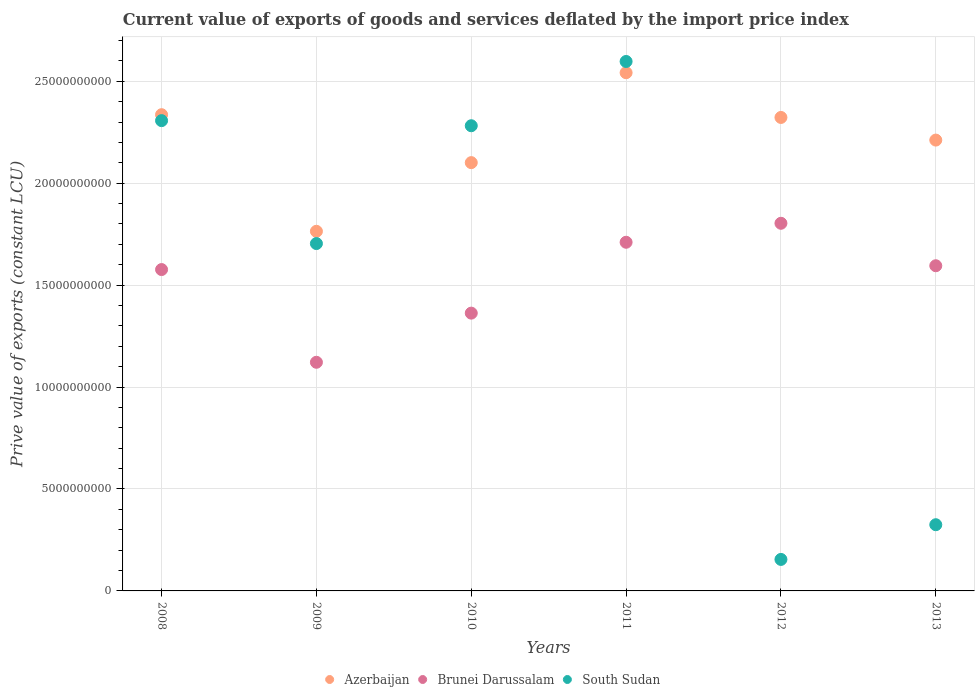What is the prive value of exports in Brunei Darussalam in 2011?
Provide a short and direct response. 1.71e+1. Across all years, what is the maximum prive value of exports in Azerbaijan?
Make the answer very short. 2.54e+1. Across all years, what is the minimum prive value of exports in South Sudan?
Your answer should be very brief. 1.55e+09. In which year was the prive value of exports in Azerbaijan maximum?
Make the answer very short. 2011. What is the total prive value of exports in South Sudan in the graph?
Provide a short and direct response. 9.37e+1. What is the difference between the prive value of exports in South Sudan in 2009 and that in 2011?
Provide a succinct answer. -8.93e+09. What is the difference between the prive value of exports in Azerbaijan in 2011 and the prive value of exports in Brunei Darussalam in 2009?
Your answer should be compact. 1.42e+1. What is the average prive value of exports in Azerbaijan per year?
Your response must be concise. 2.21e+1. In the year 2008, what is the difference between the prive value of exports in Brunei Darussalam and prive value of exports in Azerbaijan?
Offer a terse response. -7.60e+09. What is the ratio of the prive value of exports in South Sudan in 2010 to that in 2011?
Provide a succinct answer. 0.88. Is the difference between the prive value of exports in Brunei Darussalam in 2008 and 2011 greater than the difference between the prive value of exports in Azerbaijan in 2008 and 2011?
Offer a very short reply. Yes. What is the difference between the highest and the second highest prive value of exports in Brunei Darussalam?
Give a very brief answer. 9.31e+08. What is the difference between the highest and the lowest prive value of exports in Brunei Darussalam?
Provide a short and direct response. 6.82e+09. Does the prive value of exports in Brunei Darussalam monotonically increase over the years?
Your response must be concise. No. Is the prive value of exports in South Sudan strictly greater than the prive value of exports in Azerbaijan over the years?
Provide a short and direct response. No. How many dotlines are there?
Give a very brief answer. 3. How many years are there in the graph?
Provide a short and direct response. 6. Are the values on the major ticks of Y-axis written in scientific E-notation?
Give a very brief answer. No. How many legend labels are there?
Give a very brief answer. 3. What is the title of the graph?
Offer a very short reply. Current value of exports of goods and services deflated by the import price index. Does "Micronesia" appear as one of the legend labels in the graph?
Provide a short and direct response. No. What is the label or title of the X-axis?
Offer a very short reply. Years. What is the label or title of the Y-axis?
Make the answer very short. Prive value of exports (constant LCU). What is the Prive value of exports (constant LCU) of Azerbaijan in 2008?
Provide a succinct answer. 2.34e+1. What is the Prive value of exports (constant LCU) in Brunei Darussalam in 2008?
Ensure brevity in your answer.  1.58e+1. What is the Prive value of exports (constant LCU) of South Sudan in 2008?
Ensure brevity in your answer.  2.31e+1. What is the Prive value of exports (constant LCU) of Azerbaijan in 2009?
Offer a very short reply. 1.76e+1. What is the Prive value of exports (constant LCU) of Brunei Darussalam in 2009?
Provide a succinct answer. 1.12e+1. What is the Prive value of exports (constant LCU) in South Sudan in 2009?
Ensure brevity in your answer.  1.70e+1. What is the Prive value of exports (constant LCU) of Azerbaijan in 2010?
Ensure brevity in your answer.  2.10e+1. What is the Prive value of exports (constant LCU) of Brunei Darussalam in 2010?
Your answer should be compact. 1.36e+1. What is the Prive value of exports (constant LCU) in South Sudan in 2010?
Offer a very short reply. 2.28e+1. What is the Prive value of exports (constant LCU) in Azerbaijan in 2011?
Provide a succinct answer. 2.54e+1. What is the Prive value of exports (constant LCU) in Brunei Darussalam in 2011?
Your answer should be compact. 1.71e+1. What is the Prive value of exports (constant LCU) of South Sudan in 2011?
Ensure brevity in your answer.  2.60e+1. What is the Prive value of exports (constant LCU) in Azerbaijan in 2012?
Offer a very short reply. 2.32e+1. What is the Prive value of exports (constant LCU) in Brunei Darussalam in 2012?
Make the answer very short. 1.80e+1. What is the Prive value of exports (constant LCU) in South Sudan in 2012?
Your response must be concise. 1.55e+09. What is the Prive value of exports (constant LCU) of Azerbaijan in 2013?
Provide a short and direct response. 2.21e+1. What is the Prive value of exports (constant LCU) of Brunei Darussalam in 2013?
Your response must be concise. 1.60e+1. What is the Prive value of exports (constant LCU) of South Sudan in 2013?
Your answer should be very brief. 3.25e+09. Across all years, what is the maximum Prive value of exports (constant LCU) in Azerbaijan?
Offer a terse response. 2.54e+1. Across all years, what is the maximum Prive value of exports (constant LCU) in Brunei Darussalam?
Offer a terse response. 1.80e+1. Across all years, what is the maximum Prive value of exports (constant LCU) of South Sudan?
Offer a terse response. 2.60e+1. Across all years, what is the minimum Prive value of exports (constant LCU) in Azerbaijan?
Your answer should be compact. 1.76e+1. Across all years, what is the minimum Prive value of exports (constant LCU) of Brunei Darussalam?
Give a very brief answer. 1.12e+1. Across all years, what is the minimum Prive value of exports (constant LCU) in South Sudan?
Make the answer very short. 1.55e+09. What is the total Prive value of exports (constant LCU) in Azerbaijan in the graph?
Provide a short and direct response. 1.33e+11. What is the total Prive value of exports (constant LCU) of Brunei Darussalam in the graph?
Your answer should be very brief. 9.17e+1. What is the total Prive value of exports (constant LCU) of South Sudan in the graph?
Make the answer very short. 9.37e+1. What is the difference between the Prive value of exports (constant LCU) of Azerbaijan in 2008 and that in 2009?
Provide a succinct answer. 5.72e+09. What is the difference between the Prive value of exports (constant LCU) in Brunei Darussalam in 2008 and that in 2009?
Ensure brevity in your answer.  4.55e+09. What is the difference between the Prive value of exports (constant LCU) in South Sudan in 2008 and that in 2009?
Offer a very short reply. 6.03e+09. What is the difference between the Prive value of exports (constant LCU) of Azerbaijan in 2008 and that in 2010?
Offer a very short reply. 2.35e+09. What is the difference between the Prive value of exports (constant LCU) of Brunei Darussalam in 2008 and that in 2010?
Your response must be concise. 2.14e+09. What is the difference between the Prive value of exports (constant LCU) in South Sudan in 2008 and that in 2010?
Your response must be concise. 2.50e+08. What is the difference between the Prive value of exports (constant LCU) in Azerbaijan in 2008 and that in 2011?
Keep it short and to the point. -2.06e+09. What is the difference between the Prive value of exports (constant LCU) in Brunei Darussalam in 2008 and that in 2011?
Offer a terse response. -1.34e+09. What is the difference between the Prive value of exports (constant LCU) in South Sudan in 2008 and that in 2011?
Provide a short and direct response. -2.90e+09. What is the difference between the Prive value of exports (constant LCU) of Azerbaijan in 2008 and that in 2012?
Make the answer very short. 1.35e+08. What is the difference between the Prive value of exports (constant LCU) of Brunei Darussalam in 2008 and that in 2012?
Your response must be concise. -2.27e+09. What is the difference between the Prive value of exports (constant LCU) of South Sudan in 2008 and that in 2012?
Ensure brevity in your answer.  2.15e+1. What is the difference between the Prive value of exports (constant LCU) of Azerbaijan in 2008 and that in 2013?
Your response must be concise. 1.25e+09. What is the difference between the Prive value of exports (constant LCU) of Brunei Darussalam in 2008 and that in 2013?
Make the answer very short. -1.87e+08. What is the difference between the Prive value of exports (constant LCU) in South Sudan in 2008 and that in 2013?
Make the answer very short. 1.98e+1. What is the difference between the Prive value of exports (constant LCU) of Azerbaijan in 2009 and that in 2010?
Ensure brevity in your answer.  -3.37e+09. What is the difference between the Prive value of exports (constant LCU) of Brunei Darussalam in 2009 and that in 2010?
Make the answer very short. -2.41e+09. What is the difference between the Prive value of exports (constant LCU) of South Sudan in 2009 and that in 2010?
Make the answer very short. -5.78e+09. What is the difference between the Prive value of exports (constant LCU) in Azerbaijan in 2009 and that in 2011?
Offer a very short reply. -7.78e+09. What is the difference between the Prive value of exports (constant LCU) in Brunei Darussalam in 2009 and that in 2011?
Your answer should be very brief. -5.89e+09. What is the difference between the Prive value of exports (constant LCU) in South Sudan in 2009 and that in 2011?
Keep it short and to the point. -8.93e+09. What is the difference between the Prive value of exports (constant LCU) of Azerbaijan in 2009 and that in 2012?
Your answer should be compact. -5.58e+09. What is the difference between the Prive value of exports (constant LCU) of Brunei Darussalam in 2009 and that in 2012?
Offer a terse response. -6.82e+09. What is the difference between the Prive value of exports (constant LCU) in South Sudan in 2009 and that in 2012?
Make the answer very short. 1.55e+1. What is the difference between the Prive value of exports (constant LCU) of Azerbaijan in 2009 and that in 2013?
Provide a short and direct response. -4.47e+09. What is the difference between the Prive value of exports (constant LCU) in Brunei Darussalam in 2009 and that in 2013?
Offer a very short reply. -4.74e+09. What is the difference between the Prive value of exports (constant LCU) of South Sudan in 2009 and that in 2013?
Keep it short and to the point. 1.38e+1. What is the difference between the Prive value of exports (constant LCU) of Azerbaijan in 2010 and that in 2011?
Your answer should be very brief. -4.41e+09. What is the difference between the Prive value of exports (constant LCU) in Brunei Darussalam in 2010 and that in 2011?
Ensure brevity in your answer.  -3.48e+09. What is the difference between the Prive value of exports (constant LCU) in South Sudan in 2010 and that in 2011?
Give a very brief answer. -3.15e+09. What is the difference between the Prive value of exports (constant LCU) of Azerbaijan in 2010 and that in 2012?
Offer a terse response. -2.22e+09. What is the difference between the Prive value of exports (constant LCU) in Brunei Darussalam in 2010 and that in 2012?
Your answer should be very brief. -4.41e+09. What is the difference between the Prive value of exports (constant LCU) of South Sudan in 2010 and that in 2012?
Provide a short and direct response. 2.13e+1. What is the difference between the Prive value of exports (constant LCU) in Azerbaijan in 2010 and that in 2013?
Provide a short and direct response. -1.11e+09. What is the difference between the Prive value of exports (constant LCU) of Brunei Darussalam in 2010 and that in 2013?
Offer a very short reply. -2.33e+09. What is the difference between the Prive value of exports (constant LCU) in South Sudan in 2010 and that in 2013?
Your answer should be very brief. 1.96e+1. What is the difference between the Prive value of exports (constant LCU) of Azerbaijan in 2011 and that in 2012?
Provide a succinct answer. 2.19e+09. What is the difference between the Prive value of exports (constant LCU) in Brunei Darussalam in 2011 and that in 2012?
Offer a terse response. -9.31e+08. What is the difference between the Prive value of exports (constant LCU) of South Sudan in 2011 and that in 2012?
Provide a succinct answer. 2.44e+1. What is the difference between the Prive value of exports (constant LCU) of Azerbaijan in 2011 and that in 2013?
Your answer should be compact. 3.31e+09. What is the difference between the Prive value of exports (constant LCU) of Brunei Darussalam in 2011 and that in 2013?
Keep it short and to the point. 1.15e+09. What is the difference between the Prive value of exports (constant LCU) in South Sudan in 2011 and that in 2013?
Your answer should be very brief. 2.27e+1. What is the difference between the Prive value of exports (constant LCU) of Azerbaijan in 2012 and that in 2013?
Offer a terse response. 1.11e+09. What is the difference between the Prive value of exports (constant LCU) of Brunei Darussalam in 2012 and that in 2013?
Keep it short and to the point. 2.08e+09. What is the difference between the Prive value of exports (constant LCU) in South Sudan in 2012 and that in 2013?
Make the answer very short. -1.70e+09. What is the difference between the Prive value of exports (constant LCU) in Azerbaijan in 2008 and the Prive value of exports (constant LCU) in Brunei Darussalam in 2009?
Offer a very short reply. 1.21e+1. What is the difference between the Prive value of exports (constant LCU) in Azerbaijan in 2008 and the Prive value of exports (constant LCU) in South Sudan in 2009?
Ensure brevity in your answer.  6.32e+09. What is the difference between the Prive value of exports (constant LCU) in Brunei Darussalam in 2008 and the Prive value of exports (constant LCU) in South Sudan in 2009?
Your answer should be compact. -1.28e+09. What is the difference between the Prive value of exports (constant LCU) of Azerbaijan in 2008 and the Prive value of exports (constant LCU) of Brunei Darussalam in 2010?
Provide a short and direct response. 9.73e+09. What is the difference between the Prive value of exports (constant LCU) in Azerbaijan in 2008 and the Prive value of exports (constant LCU) in South Sudan in 2010?
Your answer should be very brief. 5.42e+08. What is the difference between the Prive value of exports (constant LCU) of Brunei Darussalam in 2008 and the Prive value of exports (constant LCU) of South Sudan in 2010?
Your answer should be very brief. -7.06e+09. What is the difference between the Prive value of exports (constant LCU) in Azerbaijan in 2008 and the Prive value of exports (constant LCU) in Brunei Darussalam in 2011?
Your answer should be compact. 6.26e+09. What is the difference between the Prive value of exports (constant LCU) of Azerbaijan in 2008 and the Prive value of exports (constant LCU) of South Sudan in 2011?
Provide a succinct answer. -2.61e+09. What is the difference between the Prive value of exports (constant LCU) in Brunei Darussalam in 2008 and the Prive value of exports (constant LCU) in South Sudan in 2011?
Make the answer very short. -1.02e+1. What is the difference between the Prive value of exports (constant LCU) in Azerbaijan in 2008 and the Prive value of exports (constant LCU) in Brunei Darussalam in 2012?
Offer a terse response. 5.33e+09. What is the difference between the Prive value of exports (constant LCU) in Azerbaijan in 2008 and the Prive value of exports (constant LCU) in South Sudan in 2012?
Your answer should be very brief. 2.18e+1. What is the difference between the Prive value of exports (constant LCU) in Brunei Darussalam in 2008 and the Prive value of exports (constant LCU) in South Sudan in 2012?
Provide a short and direct response. 1.42e+1. What is the difference between the Prive value of exports (constant LCU) in Azerbaijan in 2008 and the Prive value of exports (constant LCU) in Brunei Darussalam in 2013?
Provide a short and direct response. 7.41e+09. What is the difference between the Prive value of exports (constant LCU) of Azerbaijan in 2008 and the Prive value of exports (constant LCU) of South Sudan in 2013?
Offer a very short reply. 2.01e+1. What is the difference between the Prive value of exports (constant LCU) in Brunei Darussalam in 2008 and the Prive value of exports (constant LCU) in South Sudan in 2013?
Your response must be concise. 1.25e+1. What is the difference between the Prive value of exports (constant LCU) in Azerbaijan in 2009 and the Prive value of exports (constant LCU) in Brunei Darussalam in 2010?
Make the answer very short. 4.01e+09. What is the difference between the Prive value of exports (constant LCU) of Azerbaijan in 2009 and the Prive value of exports (constant LCU) of South Sudan in 2010?
Keep it short and to the point. -5.18e+09. What is the difference between the Prive value of exports (constant LCU) of Brunei Darussalam in 2009 and the Prive value of exports (constant LCU) of South Sudan in 2010?
Give a very brief answer. -1.16e+1. What is the difference between the Prive value of exports (constant LCU) of Azerbaijan in 2009 and the Prive value of exports (constant LCU) of Brunei Darussalam in 2011?
Give a very brief answer. 5.38e+08. What is the difference between the Prive value of exports (constant LCU) in Azerbaijan in 2009 and the Prive value of exports (constant LCU) in South Sudan in 2011?
Give a very brief answer. -8.33e+09. What is the difference between the Prive value of exports (constant LCU) of Brunei Darussalam in 2009 and the Prive value of exports (constant LCU) of South Sudan in 2011?
Keep it short and to the point. -1.48e+1. What is the difference between the Prive value of exports (constant LCU) of Azerbaijan in 2009 and the Prive value of exports (constant LCU) of Brunei Darussalam in 2012?
Ensure brevity in your answer.  -3.93e+08. What is the difference between the Prive value of exports (constant LCU) in Azerbaijan in 2009 and the Prive value of exports (constant LCU) in South Sudan in 2012?
Give a very brief answer. 1.61e+1. What is the difference between the Prive value of exports (constant LCU) of Brunei Darussalam in 2009 and the Prive value of exports (constant LCU) of South Sudan in 2012?
Provide a succinct answer. 9.67e+09. What is the difference between the Prive value of exports (constant LCU) of Azerbaijan in 2009 and the Prive value of exports (constant LCU) of Brunei Darussalam in 2013?
Your answer should be compact. 1.69e+09. What is the difference between the Prive value of exports (constant LCU) in Azerbaijan in 2009 and the Prive value of exports (constant LCU) in South Sudan in 2013?
Keep it short and to the point. 1.44e+1. What is the difference between the Prive value of exports (constant LCU) of Brunei Darussalam in 2009 and the Prive value of exports (constant LCU) of South Sudan in 2013?
Offer a terse response. 7.97e+09. What is the difference between the Prive value of exports (constant LCU) in Azerbaijan in 2010 and the Prive value of exports (constant LCU) in Brunei Darussalam in 2011?
Make the answer very short. 3.91e+09. What is the difference between the Prive value of exports (constant LCU) of Azerbaijan in 2010 and the Prive value of exports (constant LCU) of South Sudan in 2011?
Ensure brevity in your answer.  -4.96e+09. What is the difference between the Prive value of exports (constant LCU) in Brunei Darussalam in 2010 and the Prive value of exports (constant LCU) in South Sudan in 2011?
Keep it short and to the point. -1.23e+1. What is the difference between the Prive value of exports (constant LCU) in Azerbaijan in 2010 and the Prive value of exports (constant LCU) in Brunei Darussalam in 2012?
Provide a short and direct response. 2.98e+09. What is the difference between the Prive value of exports (constant LCU) in Azerbaijan in 2010 and the Prive value of exports (constant LCU) in South Sudan in 2012?
Ensure brevity in your answer.  1.95e+1. What is the difference between the Prive value of exports (constant LCU) in Brunei Darussalam in 2010 and the Prive value of exports (constant LCU) in South Sudan in 2012?
Your response must be concise. 1.21e+1. What is the difference between the Prive value of exports (constant LCU) of Azerbaijan in 2010 and the Prive value of exports (constant LCU) of Brunei Darussalam in 2013?
Give a very brief answer. 5.06e+09. What is the difference between the Prive value of exports (constant LCU) of Azerbaijan in 2010 and the Prive value of exports (constant LCU) of South Sudan in 2013?
Your answer should be compact. 1.78e+1. What is the difference between the Prive value of exports (constant LCU) of Brunei Darussalam in 2010 and the Prive value of exports (constant LCU) of South Sudan in 2013?
Your answer should be compact. 1.04e+1. What is the difference between the Prive value of exports (constant LCU) in Azerbaijan in 2011 and the Prive value of exports (constant LCU) in Brunei Darussalam in 2012?
Provide a short and direct response. 7.39e+09. What is the difference between the Prive value of exports (constant LCU) in Azerbaijan in 2011 and the Prive value of exports (constant LCU) in South Sudan in 2012?
Ensure brevity in your answer.  2.39e+1. What is the difference between the Prive value of exports (constant LCU) of Brunei Darussalam in 2011 and the Prive value of exports (constant LCU) of South Sudan in 2012?
Provide a succinct answer. 1.56e+1. What is the difference between the Prive value of exports (constant LCU) of Azerbaijan in 2011 and the Prive value of exports (constant LCU) of Brunei Darussalam in 2013?
Give a very brief answer. 9.47e+09. What is the difference between the Prive value of exports (constant LCU) in Azerbaijan in 2011 and the Prive value of exports (constant LCU) in South Sudan in 2013?
Give a very brief answer. 2.22e+1. What is the difference between the Prive value of exports (constant LCU) in Brunei Darussalam in 2011 and the Prive value of exports (constant LCU) in South Sudan in 2013?
Your response must be concise. 1.39e+1. What is the difference between the Prive value of exports (constant LCU) in Azerbaijan in 2012 and the Prive value of exports (constant LCU) in Brunei Darussalam in 2013?
Make the answer very short. 7.27e+09. What is the difference between the Prive value of exports (constant LCU) in Azerbaijan in 2012 and the Prive value of exports (constant LCU) in South Sudan in 2013?
Give a very brief answer. 2.00e+1. What is the difference between the Prive value of exports (constant LCU) in Brunei Darussalam in 2012 and the Prive value of exports (constant LCU) in South Sudan in 2013?
Keep it short and to the point. 1.48e+1. What is the average Prive value of exports (constant LCU) in Azerbaijan per year?
Provide a short and direct response. 2.21e+1. What is the average Prive value of exports (constant LCU) of Brunei Darussalam per year?
Your response must be concise. 1.53e+1. What is the average Prive value of exports (constant LCU) of South Sudan per year?
Offer a terse response. 1.56e+1. In the year 2008, what is the difference between the Prive value of exports (constant LCU) of Azerbaijan and Prive value of exports (constant LCU) of Brunei Darussalam?
Your answer should be compact. 7.60e+09. In the year 2008, what is the difference between the Prive value of exports (constant LCU) in Azerbaijan and Prive value of exports (constant LCU) in South Sudan?
Make the answer very short. 2.92e+08. In the year 2008, what is the difference between the Prive value of exports (constant LCU) in Brunei Darussalam and Prive value of exports (constant LCU) in South Sudan?
Keep it short and to the point. -7.31e+09. In the year 2009, what is the difference between the Prive value of exports (constant LCU) in Azerbaijan and Prive value of exports (constant LCU) in Brunei Darussalam?
Your response must be concise. 6.43e+09. In the year 2009, what is the difference between the Prive value of exports (constant LCU) in Azerbaijan and Prive value of exports (constant LCU) in South Sudan?
Ensure brevity in your answer.  6.01e+08. In the year 2009, what is the difference between the Prive value of exports (constant LCU) in Brunei Darussalam and Prive value of exports (constant LCU) in South Sudan?
Make the answer very short. -5.82e+09. In the year 2010, what is the difference between the Prive value of exports (constant LCU) of Azerbaijan and Prive value of exports (constant LCU) of Brunei Darussalam?
Provide a succinct answer. 7.38e+09. In the year 2010, what is the difference between the Prive value of exports (constant LCU) in Azerbaijan and Prive value of exports (constant LCU) in South Sudan?
Offer a terse response. -1.81e+09. In the year 2010, what is the difference between the Prive value of exports (constant LCU) of Brunei Darussalam and Prive value of exports (constant LCU) of South Sudan?
Your answer should be very brief. -9.19e+09. In the year 2011, what is the difference between the Prive value of exports (constant LCU) in Azerbaijan and Prive value of exports (constant LCU) in Brunei Darussalam?
Your answer should be compact. 8.32e+09. In the year 2011, what is the difference between the Prive value of exports (constant LCU) of Azerbaijan and Prive value of exports (constant LCU) of South Sudan?
Your response must be concise. -5.51e+08. In the year 2011, what is the difference between the Prive value of exports (constant LCU) in Brunei Darussalam and Prive value of exports (constant LCU) in South Sudan?
Offer a very short reply. -8.87e+09. In the year 2012, what is the difference between the Prive value of exports (constant LCU) of Azerbaijan and Prive value of exports (constant LCU) of Brunei Darussalam?
Ensure brevity in your answer.  5.19e+09. In the year 2012, what is the difference between the Prive value of exports (constant LCU) in Azerbaijan and Prive value of exports (constant LCU) in South Sudan?
Make the answer very short. 2.17e+1. In the year 2012, what is the difference between the Prive value of exports (constant LCU) in Brunei Darussalam and Prive value of exports (constant LCU) in South Sudan?
Ensure brevity in your answer.  1.65e+1. In the year 2013, what is the difference between the Prive value of exports (constant LCU) of Azerbaijan and Prive value of exports (constant LCU) of Brunei Darussalam?
Your response must be concise. 6.16e+09. In the year 2013, what is the difference between the Prive value of exports (constant LCU) of Azerbaijan and Prive value of exports (constant LCU) of South Sudan?
Give a very brief answer. 1.89e+1. In the year 2013, what is the difference between the Prive value of exports (constant LCU) in Brunei Darussalam and Prive value of exports (constant LCU) in South Sudan?
Give a very brief answer. 1.27e+1. What is the ratio of the Prive value of exports (constant LCU) in Azerbaijan in 2008 to that in 2009?
Your answer should be compact. 1.32. What is the ratio of the Prive value of exports (constant LCU) in Brunei Darussalam in 2008 to that in 2009?
Give a very brief answer. 1.41. What is the ratio of the Prive value of exports (constant LCU) of South Sudan in 2008 to that in 2009?
Offer a terse response. 1.35. What is the ratio of the Prive value of exports (constant LCU) in Azerbaijan in 2008 to that in 2010?
Offer a terse response. 1.11. What is the ratio of the Prive value of exports (constant LCU) of Brunei Darussalam in 2008 to that in 2010?
Ensure brevity in your answer.  1.16. What is the ratio of the Prive value of exports (constant LCU) in South Sudan in 2008 to that in 2010?
Give a very brief answer. 1.01. What is the ratio of the Prive value of exports (constant LCU) in Azerbaijan in 2008 to that in 2011?
Provide a short and direct response. 0.92. What is the ratio of the Prive value of exports (constant LCU) in Brunei Darussalam in 2008 to that in 2011?
Give a very brief answer. 0.92. What is the ratio of the Prive value of exports (constant LCU) of South Sudan in 2008 to that in 2011?
Provide a succinct answer. 0.89. What is the ratio of the Prive value of exports (constant LCU) of Brunei Darussalam in 2008 to that in 2012?
Your answer should be compact. 0.87. What is the ratio of the Prive value of exports (constant LCU) in South Sudan in 2008 to that in 2012?
Offer a terse response. 14.93. What is the ratio of the Prive value of exports (constant LCU) in Azerbaijan in 2008 to that in 2013?
Your answer should be very brief. 1.06. What is the ratio of the Prive value of exports (constant LCU) of Brunei Darussalam in 2008 to that in 2013?
Provide a succinct answer. 0.99. What is the ratio of the Prive value of exports (constant LCU) of South Sudan in 2008 to that in 2013?
Your answer should be compact. 7.1. What is the ratio of the Prive value of exports (constant LCU) of Azerbaijan in 2009 to that in 2010?
Keep it short and to the point. 0.84. What is the ratio of the Prive value of exports (constant LCU) of Brunei Darussalam in 2009 to that in 2010?
Make the answer very short. 0.82. What is the ratio of the Prive value of exports (constant LCU) of South Sudan in 2009 to that in 2010?
Give a very brief answer. 0.75. What is the ratio of the Prive value of exports (constant LCU) of Azerbaijan in 2009 to that in 2011?
Give a very brief answer. 0.69. What is the ratio of the Prive value of exports (constant LCU) of Brunei Darussalam in 2009 to that in 2011?
Provide a short and direct response. 0.66. What is the ratio of the Prive value of exports (constant LCU) in South Sudan in 2009 to that in 2011?
Offer a terse response. 0.66. What is the ratio of the Prive value of exports (constant LCU) of Azerbaijan in 2009 to that in 2012?
Provide a short and direct response. 0.76. What is the ratio of the Prive value of exports (constant LCU) in Brunei Darussalam in 2009 to that in 2012?
Your response must be concise. 0.62. What is the ratio of the Prive value of exports (constant LCU) of South Sudan in 2009 to that in 2012?
Give a very brief answer. 11.03. What is the ratio of the Prive value of exports (constant LCU) of Azerbaijan in 2009 to that in 2013?
Your answer should be compact. 0.8. What is the ratio of the Prive value of exports (constant LCU) of Brunei Darussalam in 2009 to that in 2013?
Offer a terse response. 0.7. What is the ratio of the Prive value of exports (constant LCU) in South Sudan in 2009 to that in 2013?
Provide a short and direct response. 5.25. What is the ratio of the Prive value of exports (constant LCU) in Azerbaijan in 2010 to that in 2011?
Give a very brief answer. 0.83. What is the ratio of the Prive value of exports (constant LCU) of Brunei Darussalam in 2010 to that in 2011?
Make the answer very short. 0.8. What is the ratio of the Prive value of exports (constant LCU) of South Sudan in 2010 to that in 2011?
Your answer should be very brief. 0.88. What is the ratio of the Prive value of exports (constant LCU) of Azerbaijan in 2010 to that in 2012?
Ensure brevity in your answer.  0.9. What is the ratio of the Prive value of exports (constant LCU) in Brunei Darussalam in 2010 to that in 2012?
Keep it short and to the point. 0.76. What is the ratio of the Prive value of exports (constant LCU) in South Sudan in 2010 to that in 2012?
Make the answer very short. 14.77. What is the ratio of the Prive value of exports (constant LCU) of Brunei Darussalam in 2010 to that in 2013?
Offer a terse response. 0.85. What is the ratio of the Prive value of exports (constant LCU) in South Sudan in 2010 to that in 2013?
Your answer should be very brief. 7.03. What is the ratio of the Prive value of exports (constant LCU) in Azerbaijan in 2011 to that in 2012?
Your response must be concise. 1.09. What is the ratio of the Prive value of exports (constant LCU) of Brunei Darussalam in 2011 to that in 2012?
Provide a short and direct response. 0.95. What is the ratio of the Prive value of exports (constant LCU) of South Sudan in 2011 to that in 2012?
Offer a terse response. 16.81. What is the ratio of the Prive value of exports (constant LCU) in Azerbaijan in 2011 to that in 2013?
Your answer should be very brief. 1.15. What is the ratio of the Prive value of exports (constant LCU) of Brunei Darussalam in 2011 to that in 2013?
Provide a short and direct response. 1.07. What is the ratio of the Prive value of exports (constant LCU) in South Sudan in 2011 to that in 2013?
Provide a succinct answer. 8. What is the ratio of the Prive value of exports (constant LCU) of Azerbaijan in 2012 to that in 2013?
Keep it short and to the point. 1.05. What is the ratio of the Prive value of exports (constant LCU) in Brunei Darussalam in 2012 to that in 2013?
Offer a very short reply. 1.13. What is the ratio of the Prive value of exports (constant LCU) of South Sudan in 2012 to that in 2013?
Your response must be concise. 0.48. What is the difference between the highest and the second highest Prive value of exports (constant LCU) of Azerbaijan?
Your response must be concise. 2.06e+09. What is the difference between the highest and the second highest Prive value of exports (constant LCU) in Brunei Darussalam?
Your answer should be very brief. 9.31e+08. What is the difference between the highest and the second highest Prive value of exports (constant LCU) in South Sudan?
Make the answer very short. 2.90e+09. What is the difference between the highest and the lowest Prive value of exports (constant LCU) of Azerbaijan?
Provide a succinct answer. 7.78e+09. What is the difference between the highest and the lowest Prive value of exports (constant LCU) of Brunei Darussalam?
Your answer should be compact. 6.82e+09. What is the difference between the highest and the lowest Prive value of exports (constant LCU) in South Sudan?
Ensure brevity in your answer.  2.44e+1. 